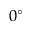<formula> <loc_0><loc_0><loc_500><loc_500>0 ^ { \circ }</formula> 